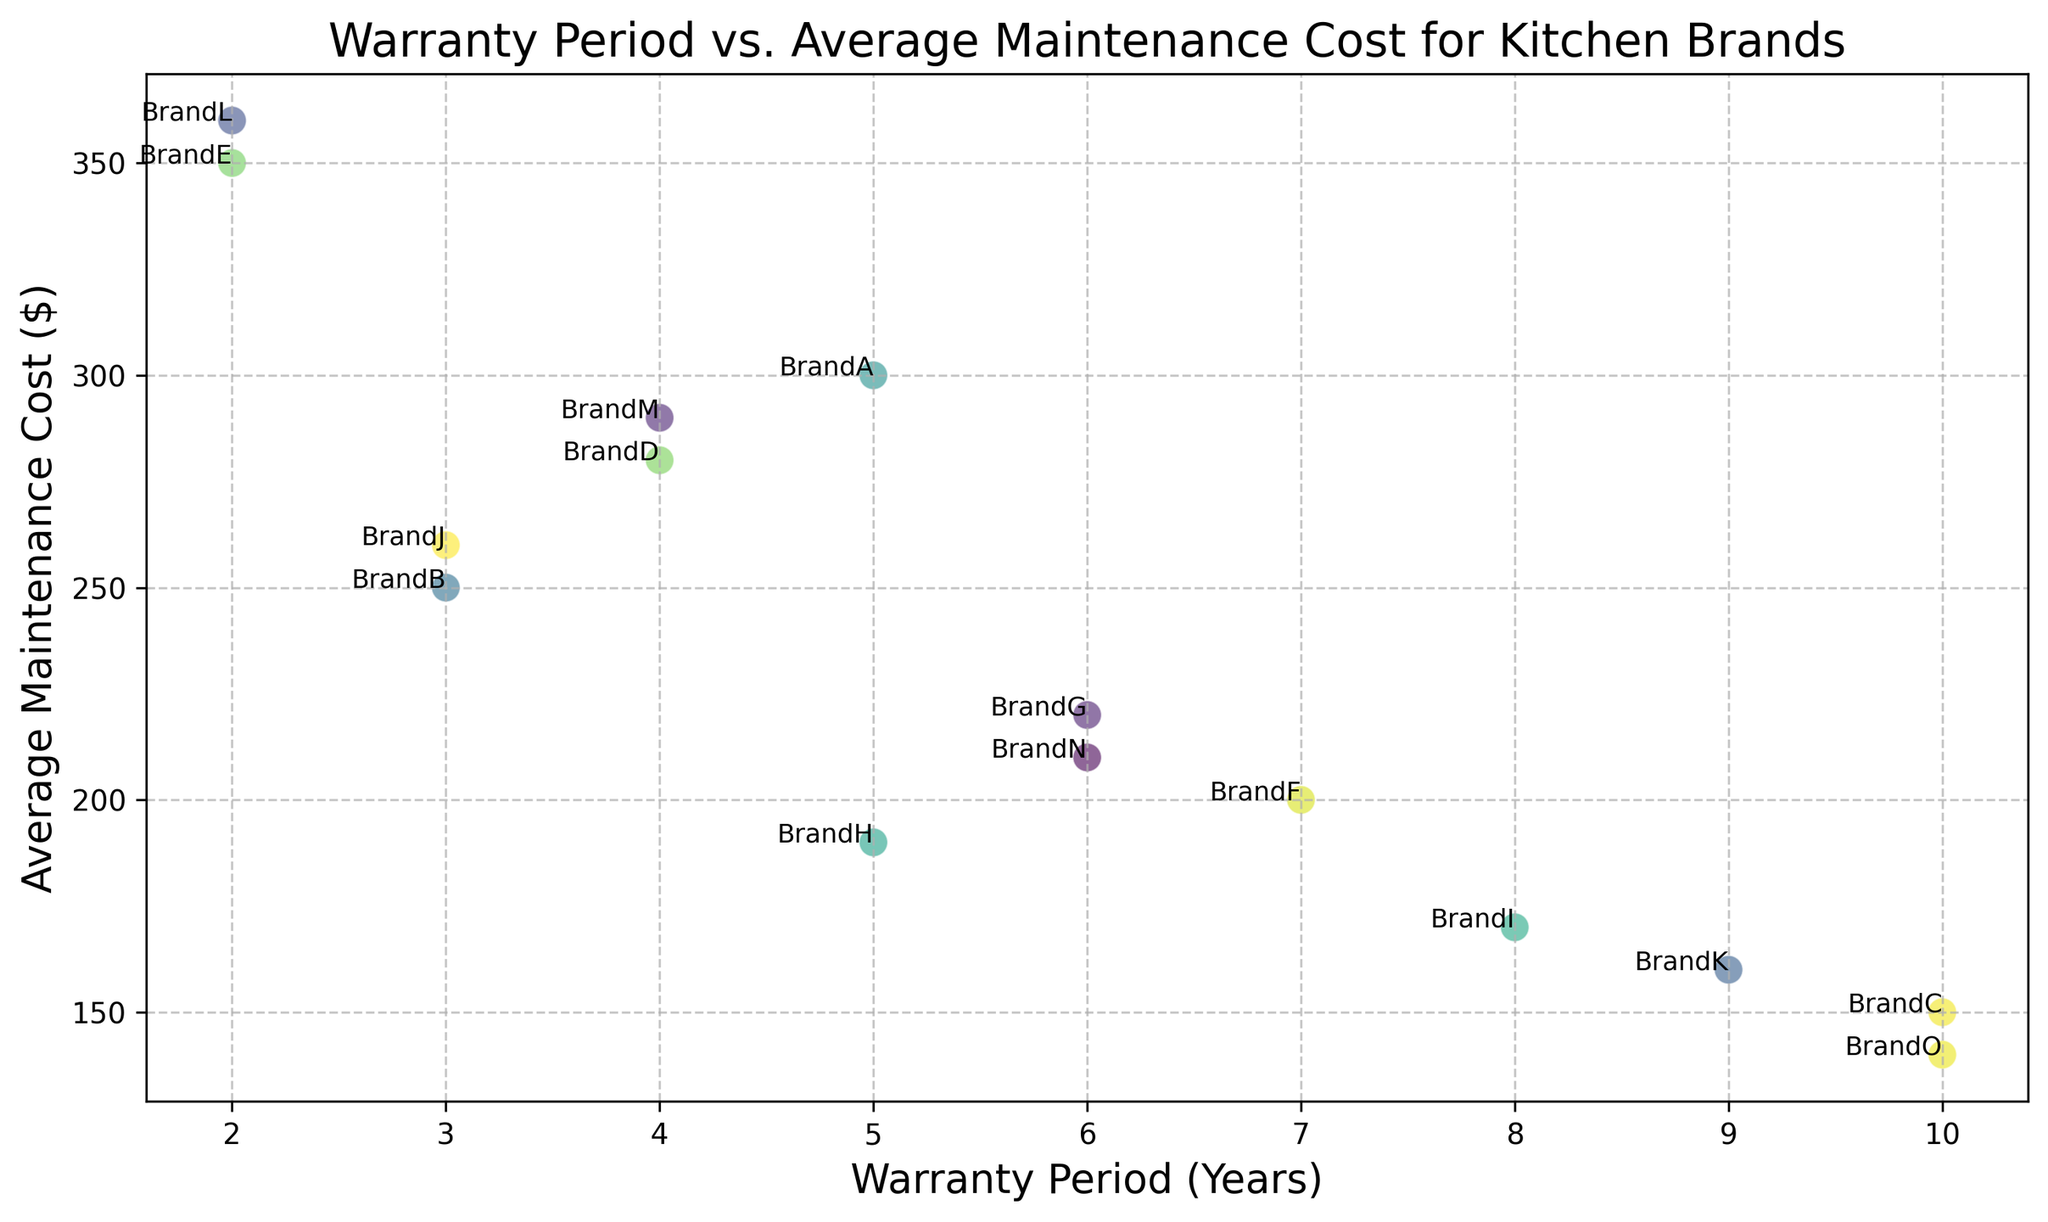What is the average maintenance cost of BrandO? Find the point labeled "BrandO" on the scatter plot, then read the y-axis value.
Answer: $140 Which brand has the longest warranty period? Identify the point farthest to the right on the x-axis, which represents the longest warranty period. The brand associated with that point is BrandC and BrandO with a warranty period of 10 years.
Answer: BrandC and BrandO Which brand has the highest average maintenance cost? Look for the point with the highest y-axis value, which indicates the highest average maintenance cost.
Answer: BrandL What is the difference in average maintenance cost between BrandE and BrandN? Find BrandE and BrandN on the scatter plot and note their y-axis values. Subtract the average maintenance cost of BrandN ($210) from BrandE ($350).
Answer: $140 How many brands have an average maintenance cost of less than $200? Count the number of points that lie below the $200 mark on the y-axis. These include BrandC, BrandH, BrandI, BrandK, and BrandO.
Answer: 5 Which brands have a warranty period of 5 years? Look for points on the scatter plot that align with 5 years on the x-axis, and read the labels. They are BrandA and BrandH.
Answer: BrandA and BrandH Do any brands have both a warranty period greater than 5 years and an average maintenance cost below $200? Identify points that lie to the right of the 5-year mark on the x-axis and below the $200 mark on the y-axis. Here brands BrandI, BrandK, and BrandO meet these criteria.
Answer: BrandI, BrandK, and BrandO What is the median average maintenance cost of all brands? List all average maintenance costs in numerical order ($140, $150, $160, $170, $190, $200, $210, $220, $250, $260, $280, $290, $300, $350, $360) and find the middle value. There are 15 values, so the median is the 8th value.
Answer: $220 Which brand has a lower average maintenance cost: BrandB or BrandJ? Compare the y-axis values for points labeled "BrandB" and "BrandJ".
Answer: BrandB 